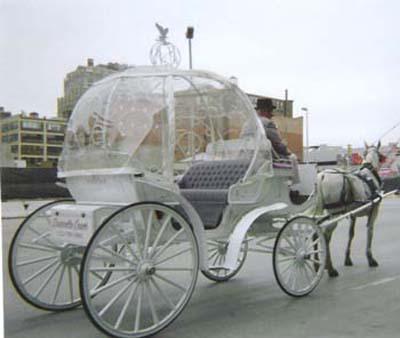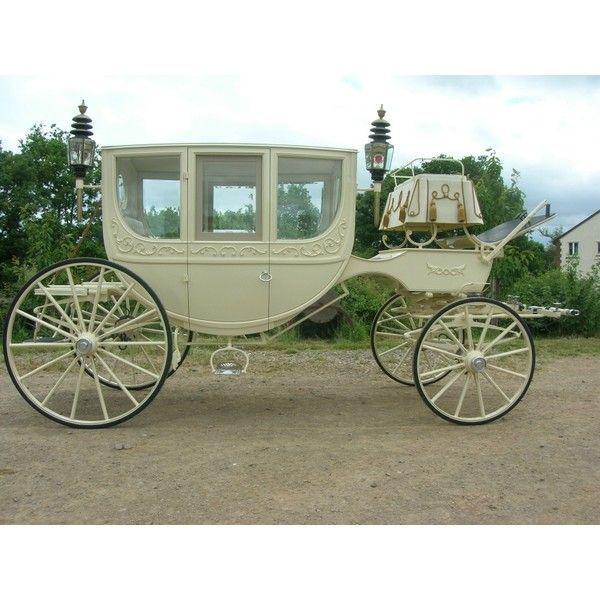The first image is the image on the left, the second image is the image on the right. Examine the images to the left and right. Is the description "There is a white carriage led by a white horse in the left image." accurate? Answer yes or no. Yes. The first image is the image on the left, the second image is the image on the right. Considering the images on both sides, is "There are humans riding in a carriage in the right image." valid? Answer yes or no. No. 